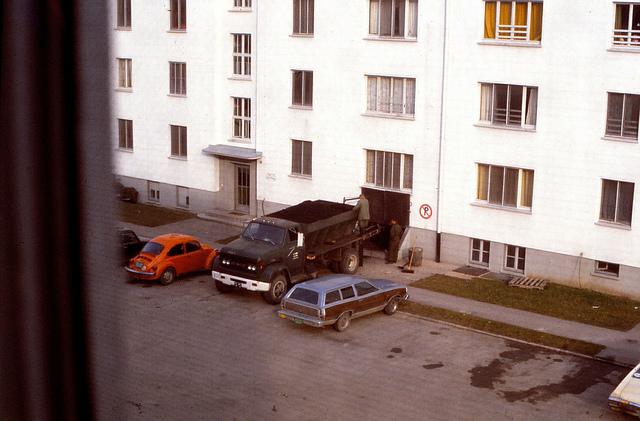What brand is the smallest car?
Be succinct. Volkswagen. What kind of car is to the left of the truck?
Be succinct. Beetle. How many vehicles are shown?
Quick response, please. 4. 